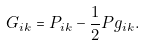<formula> <loc_0><loc_0><loc_500><loc_500>G _ { i k } = P _ { i k } - \frac { 1 } { 2 } P g _ { i k } .</formula> 